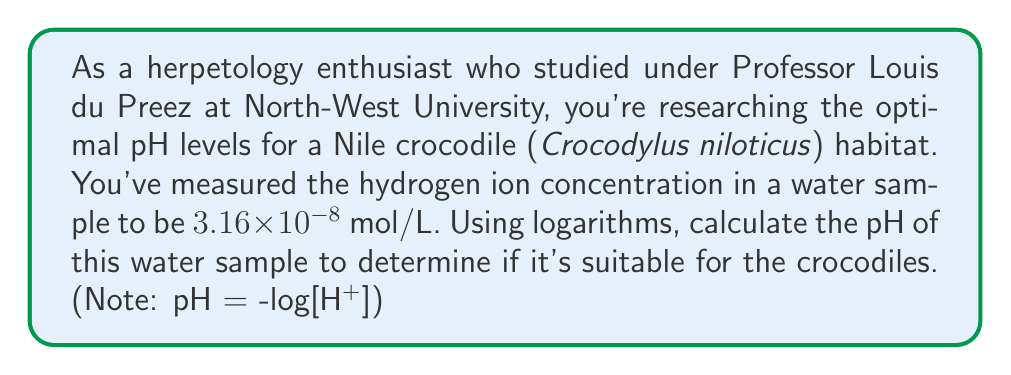Solve this math problem. To solve this problem, we'll use the formula for pH and the given hydrogen ion concentration:

1) The formula for pH is:
   $$ \text{pH} = -\log[\text{H}^+] $$
   where $[\text{H}^+]$ is the hydrogen ion concentration in mol/L.

2) We're given that $[\text{H}^+] = 3.16 \times 10^{-8}$ mol/L.

3) Substituting this into our pH formula:
   $$ \text{pH} = -\log(3.16 \times 10^{-8}) $$

4) Using the properties of logarithms, we can split this into:
   $$ \text{pH} = -(\log(3.16) + \log(10^{-8})) $$

5) Simplify:
   $$ \text{pH} = -(\log(3.16) - 8) $$

6) Calculate $\log(3.16)$ (using a calculator):
   $$ \text{pH} = -(0.4997 - 8) $$

7) Simplify:
   $$ \text{pH} = -(-7.5003) = 7.5003 $$

8) Rounding to two decimal places:
   $$ \text{pH} = 7.50 $$

This pH level is close to neutral (pH 7) and is generally suitable for Nile crocodiles, which prefer slightly alkaline water.
Answer: The pH of the water sample is 7.50. 